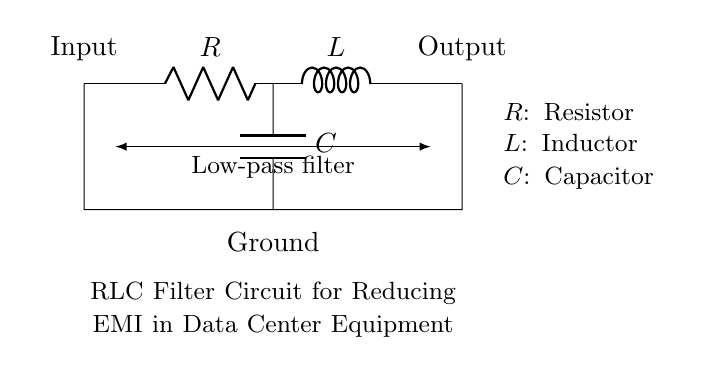What components are present in the circuit? The circuit contains one resistor, one inductor, and one capacitor, which is fundamental in an RLC circuit. These components are visually labeled in the diagram, denoting their basic functionality.
Answer: Resistor, inductor, capacitor What type of filter is this circuit designed as? The diagram indicates that this is a low-pass filter, designed to allow low-frequency signals to pass through while attenuating higher-frequency signals, which aligns with its purpose of reducing electromagnetic interference.
Answer: Low-pass filter What is the function of the resistor in this circuit? The resistor in an RLC filter circuit primarily serves to limit current, dissipate energy, and affect the overall impedance of the circuit. Its placement before the inductor and capacitor aids in controlling the signal flow.
Answer: Current limitation What is the purpose of this RLC circuit in a data center? The circuit's purpose is to reduce electromagnetic interference, which can disrupt sensitive electronic equipment in a data center, ensuring more reliable operation. This is vital in maintaining data integrity and performance.
Answer: Reducing electromagnetic interference How do the inductor and capacitor interact in this circuit? In this circuit, inductors store energy in a magnetic field, while capacitors store energy in an electric field. Together, they create resonance and filtering effects. The inductor opposes changes in current, while the capacitor opposes changes in voltage, working synergistically to control the output signal.
Answer: They create resonance and filtering effects What happens to high-frequency signals in this circuit? High-frequency signals are attenuated, meaning their amplitude decreases as they pass through the circuit. This is a key characteristic of a low-pass filter, which allows low frequencies to pass while reducing higher frequencies, effectively mitigating electromagnetic interference.
Answer: Attenuated 